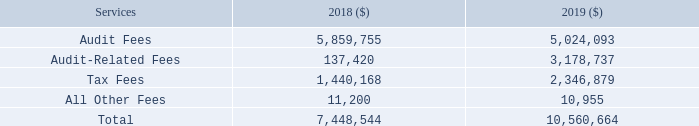Ernst & Young LLP
Ernst & Young LLP fees incurred by us for fiscal 2018 and 2019 were as follows:
Audit Fees: Audit fees for fiscal 2018 and 2019 were for professional services rendered in connection with audits of our consolidated financial statements, statutory audits of our subsidiary companies, quarterly reviews, and assistance with documents that we filed with the SEC (including our Forms 10-Q and 8-K) for periods covering fiscal 2018 and 2019.
Audit-Related Fees: Audit-related fees for 2018 and 2019 were for professional services rendered in connection with consultations with management on various accounting matters, including audit of financial
statements of a carve-out entity and sell-side due diligence with respect to our previously announced Spin-Off.
Tax Fees: Tax fees for 2018 and 2019 were for tax compliance and consulting services.
All Other Fees: Other fees in 2018 and 2019 were for access to technical accounting services.
What are the components of the fees incurred? Audit fees, audit-related fees, tax fees, all other fees. What are the other fees for in 2018 and 2019? For access to technical accounting services. What are the tax fees used for? For tax compliance and consulting services. Which year was the tax fees higher? 2,346,879 > 1,440,168
Answer: 2019. What was the change in audit fees? 5,024,093-5,859,755 
Answer: -835662. What was the percentage change in total fees from 2018 to 2019?
Answer scale should be: percent. ( 10,560,664 - 7,448,544 )/ 7,448,544 
Answer: 41.78. 